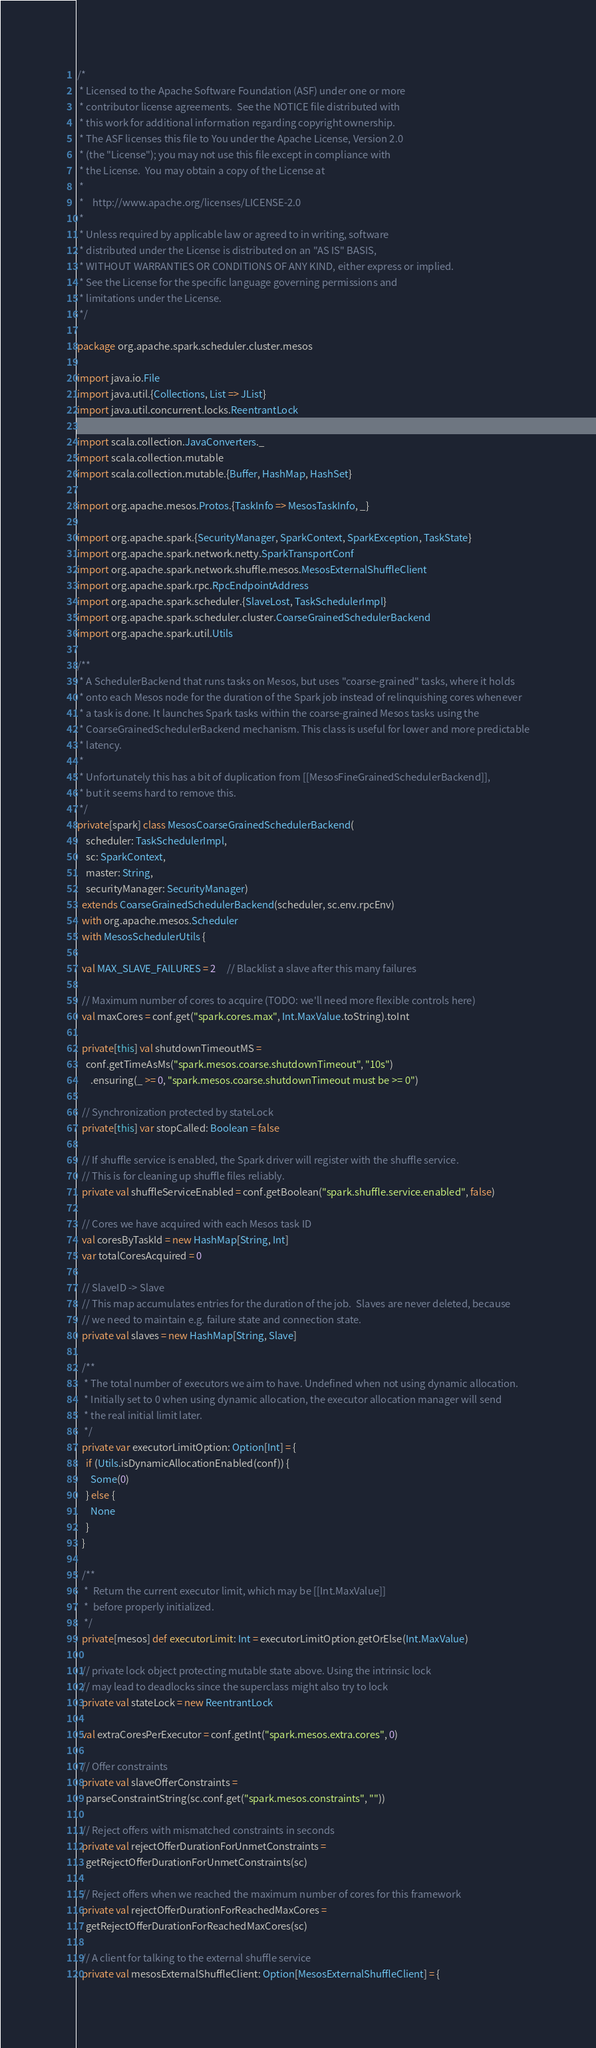Convert code to text. <code><loc_0><loc_0><loc_500><loc_500><_Scala_>/*
 * Licensed to the Apache Software Foundation (ASF) under one or more
 * contributor license agreements.  See the NOTICE file distributed with
 * this work for additional information regarding copyright ownership.
 * The ASF licenses this file to You under the Apache License, Version 2.0
 * (the "License"); you may not use this file except in compliance with
 * the License.  You may obtain a copy of the License at
 *
 *    http://www.apache.org/licenses/LICENSE-2.0
 *
 * Unless required by applicable law or agreed to in writing, software
 * distributed under the License is distributed on an "AS IS" BASIS,
 * WITHOUT WARRANTIES OR CONDITIONS OF ANY KIND, either express or implied.
 * See the License for the specific language governing permissions and
 * limitations under the License.
 */

package org.apache.spark.scheduler.cluster.mesos

import java.io.File
import java.util.{Collections, List => JList}
import java.util.concurrent.locks.ReentrantLock

import scala.collection.JavaConverters._
import scala.collection.mutable
import scala.collection.mutable.{Buffer, HashMap, HashSet}

import org.apache.mesos.Protos.{TaskInfo => MesosTaskInfo, _}

import org.apache.spark.{SecurityManager, SparkContext, SparkException, TaskState}
import org.apache.spark.network.netty.SparkTransportConf
import org.apache.spark.network.shuffle.mesos.MesosExternalShuffleClient
import org.apache.spark.rpc.RpcEndpointAddress
import org.apache.spark.scheduler.{SlaveLost, TaskSchedulerImpl}
import org.apache.spark.scheduler.cluster.CoarseGrainedSchedulerBackend
import org.apache.spark.util.Utils

/**
 * A SchedulerBackend that runs tasks on Mesos, but uses "coarse-grained" tasks, where it holds
 * onto each Mesos node for the duration of the Spark job instead of relinquishing cores whenever
 * a task is done. It launches Spark tasks within the coarse-grained Mesos tasks using the
 * CoarseGrainedSchedulerBackend mechanism. This class is useful for lower and more predictable
 * latency.
 *
 * Unfortunately this has a bit of duplication from [[MesosFineGrainedSchedulerBackend]],
 * but it seems hard to remove this.
 */
private[spark] class MesosCoarseGrainedSchedulerBackend(
    scheduler: TaskSchedulerImpl,
    sc: SparkContext,
    master: String,
    securityManager: SecurityManager)
  extends CoarseGrainedSchedulerBackend(scheduler, sc.env.rpcEnv)
  with org.apache.mesos.Scheduler
  with MesosSchedulerUtils {

  val MAX_SLAVE_FAILURES = 2     // Blacklist a slave after this many failures

  // Maximum number of cores to acquire (TODO: we'll need more flexible controls here)
  val maxCores = conf.get("spark.cores.max", Int.MaxValue.toString).toInt

  private[this] val shutdownTimeoutMS =
    conf.getTimeAsMs("spark.mesos.coarse.shutdownTimeout", "10s")
      .ensuring(_ >= 0, "spark.mesos.coarse.shutdownTimeout must be >= 0")

  // Synchronization protected by stateLock
  private[this] var stopCalled: Boolean = false

  // If shuffle service is enabled, the Spark driver will register with the shuffle service.
  // This is for cleaning up shuffle files reliably.
  private val shuffleServiceEnabled = conf.getBoolean("spark.shuffle.service.enabled", false)

  // Cores we have acquired with each Mesos task ID
  val coresByTaskId = new HashMap[String, Int]
  var totalCoresAcquired = 0

  // SlaveID -> Slave
  // This map accumulates entries for the duration of the job.  Slaves are never deleted, because
  // we need to maintain e.g. failure state and connection state.
  private val slaves = new HashMap[String, Slave]

  /**
   * The total number of executors we aim to have. Undefined when not using dynamic allocation.
   * Initially set to 0 when using dynamic allocation, the executor allocation manager will send
   * the real initial limit later.
   */
  private var executorLimitOption: Option[Int] = {
    if (Utils.isDynamicAllocationEnabled(conf)) {
      Some(0)
    } else {
      None
    }
  }

  /**
   *  Return the current executor limit, which may be [[Int.MaxValue]]
   *  before properly initialized.
   */
  private[mesos] def executorLimit: Int = executorLimitOption.getOrElse(Int.MaxValue)

  // private lock object protecting mutable state above. Using the intrinsic lock
  // may lead to deadlocks since the superclass might also try to lock
  private val stateLock = new ReentrantLock

  val extraCoresPerExecutor = conf.getInt("spark.mesos.extra.cores", 0)

  // Offer constraints
  private val slaveOfferConstraints =
    parseConstraintString(sc.conf.get("spark.mesos.constraints", ""))

  // Reject offers with mismatched constraints in seconds
  private val rejectOfferDurationForUnmetConstraints =
    getRejectOfferDurationForUnmetConstraints(sc)

  // Reject offers when we reached the maximum number of cores for this framework
  private val rejectOfferDurationForReachedMaxCores =
    getRejectOfferDurationForReachedMaxCores(sc)

  // A client for talking to the external shuffle service
  private val mesosExternalShuffleClient: Option[MesosExternalShuffleClient] = {</code> 